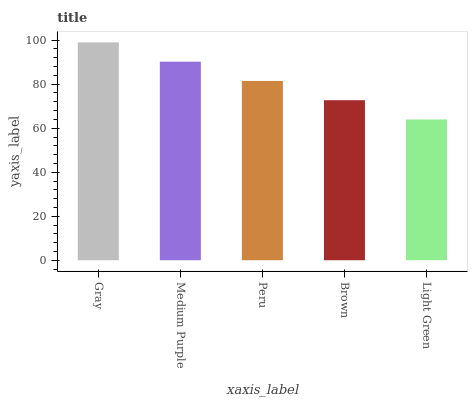Is Light Green the minimum?
Answer yes or no. Yes. Is Gray the maximum?
Answer yes or no. Yes. Is Medium Purple the minimum?
Answer yes or no. No. Is Medium Purple the maximum?
Answer yes or no. No. Is Gray greater than Medium Purple?
Answer yes or no. Yes. Is Medium Purple less than Gray?
Answer yes or no. Yes. Is Medium Purple greater than Gray?
Answer yes or no. No. Is Gray less than Medium Purple?
Answer yes or no. No. Is Peru the high median?
Answer yes or no. Yes. Is Peru the low median?
Answer yes or no. Yes. Is Gray the high median?
Answer yes or no. No. Is Medium Purple the low median?
Answer yes or no. No. 